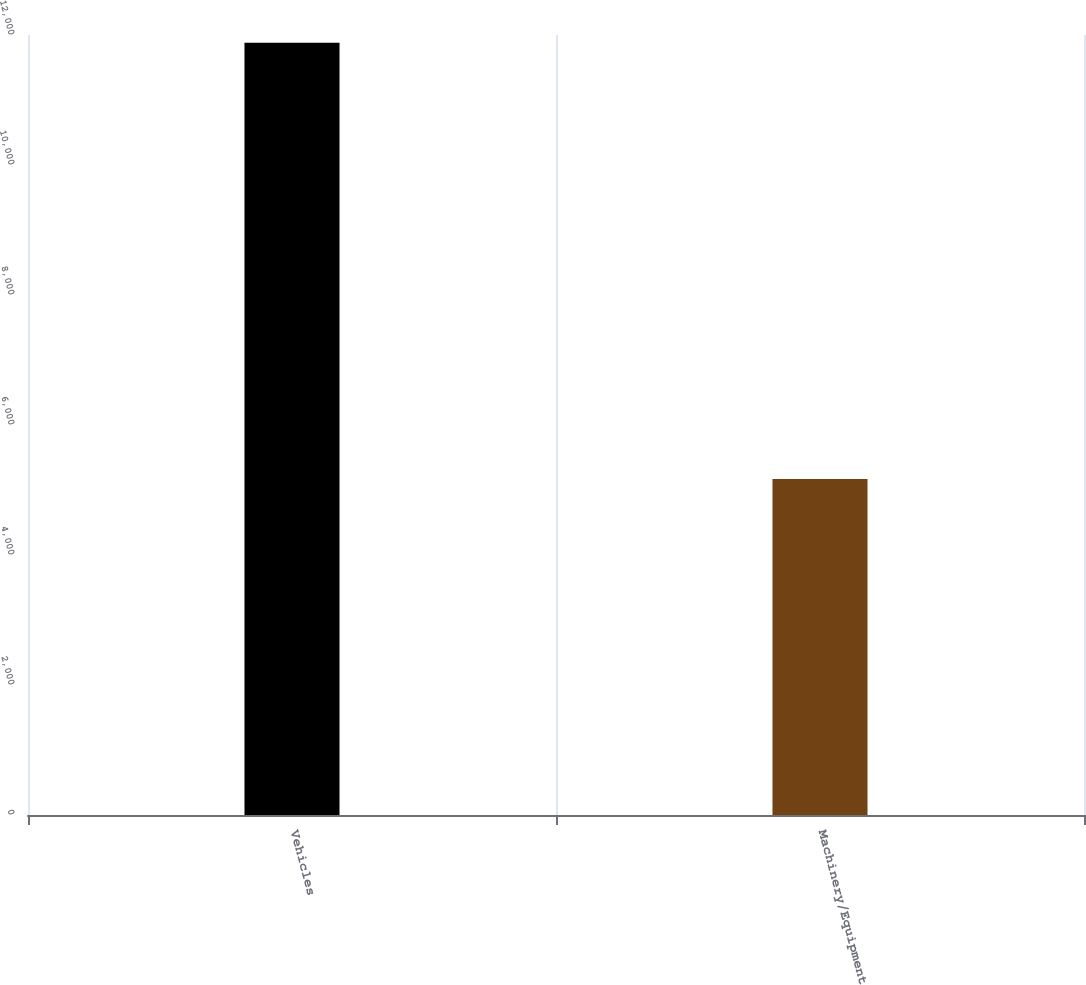Convert chart to OTSL. <chart><loc_0><loc_0><loc_500><loc_500><bar_chart><fcel>Vehicles<fcel>Machinery/Equipment<nl><fcel>11880<fcel>5171<nl></chart> 